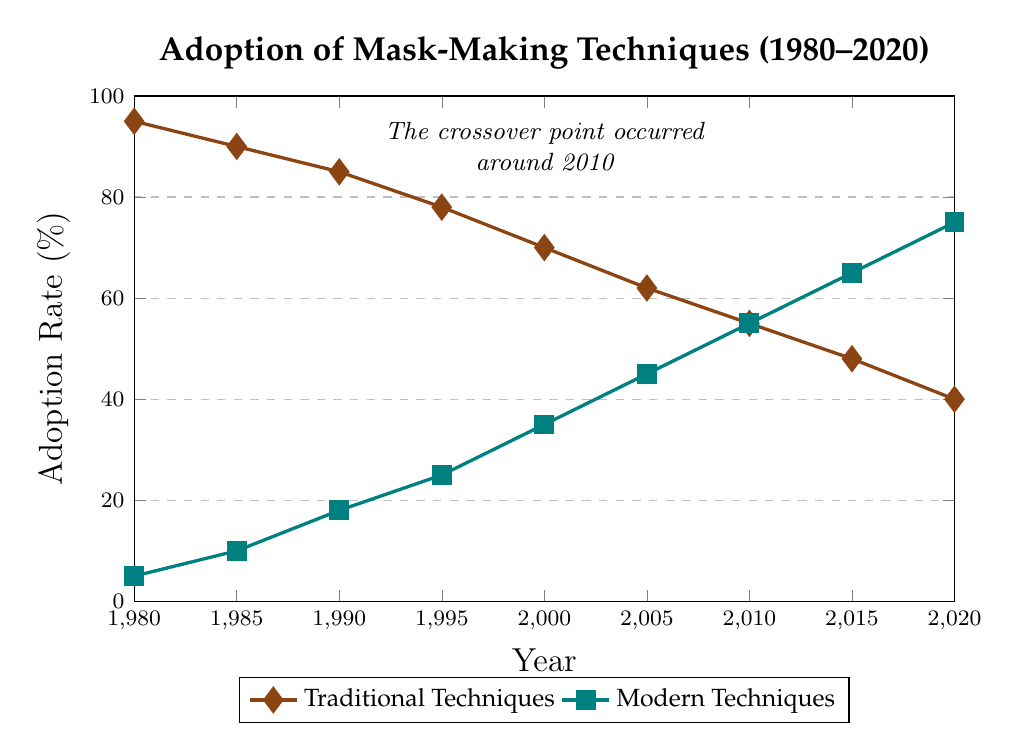What year did modern techniques surpass traditional techniques in adoption rates? The crossover point where modern techniques surpassed traditional techniques happened in 2010, as indicated in the chart by the note placed around that year.
Answer: 2010 How much did the adoption rate of traditional techniques decline from 1980 to 2020? In 1980, the adoption rate was 95%, and in 2020, it was 40%. Subtract the 2020 rate from the 1980 rate (95 - 40) to find the decline.
Answer: 55% By how much did the adoption rate of modern techniques increase between 1985 and 2000? The adoption rate for modern techniques in 1985 was 10% and in 2000 it was 35%. Subtract the 1985 rate from the 2000 rate (35 - 10) to find the increase.
Answer: 25% What was the average adoption rate of modern techniques from 1980 to 2020? The adoption rates for modern techniques over the years are: 5, 10, 18, 25, 35, 45, 55, 65, 75. Summed up: (5 + 10 + 18 + 25 + 35 + 45 + 55 + 65 + 75 = 333). There are 9 years, so the average is 333 / 9.
Answer: 37% What is the total change in the adoption rates of traditional and modern techniques from 1980 to 2020? For traditional techniques: initial (1980) 95% and final (2020) 40%, change is 95% - 40% = -55%. For modern techniques: initial (1980) 5% and final (2020) 75%, change is 75% - 5% = 70%.
Answer: Traditional: -55%, Modern: 70% Which technique had a higher adoption rate in 2005, and by how much? In 2005, the adoption rate for traditional techniques was 62%, and for modern techniques, it was 45%. Subtract the modern rate from the traditional rate (62% - 45%) to find the difference.
Answer: Traditional, by 17% What is the compounded annual growth rate (CAGR) of modern techniques' adoption rate from 1980 to 2020? Using the CAGR formula: (Final Value/Initial Value)^(1/number of periods) - 1: 
(75/5)^(1/40) - 1 ≈ 0.0716 or 7.16%
Answer: 7.16% What was the cumulative percentage adoption rate for traditional and modern techniques combined in 1990? The rates in 1990 were 85% for traditional and 18% for modern. Add these together (85% + 18%).
Answer: 103% 